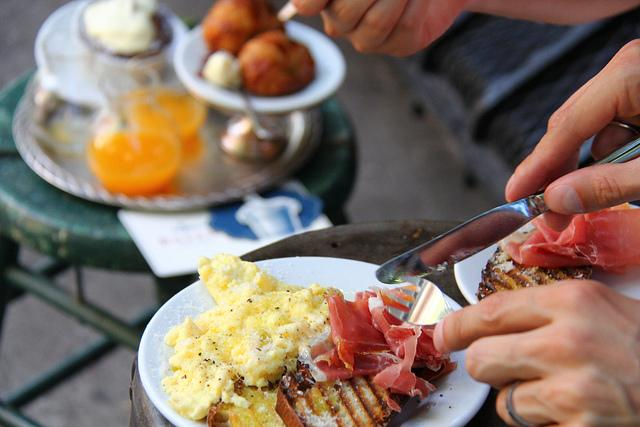What kind of fish is consumed on the side of the breakfast?

Choices:
A) bacon
B) beef
C) sausage
D) salmon salmon 